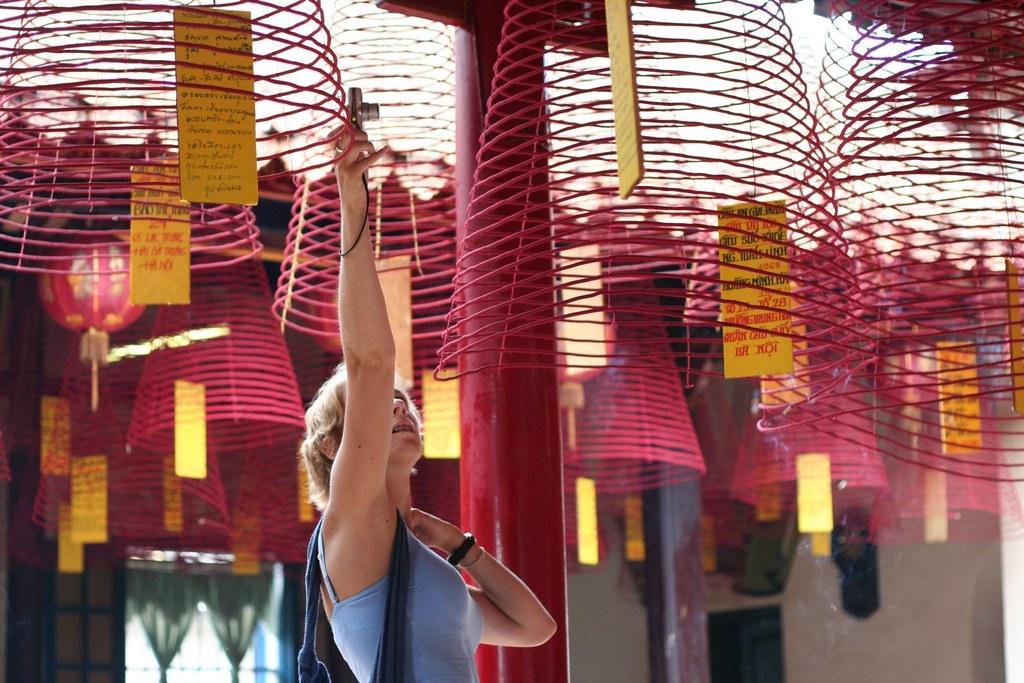Could you give a brief overview of what you see in this image? In this image we can see a lady taking picture with camera, there are some decorative objects are hanging, there are some cards with some text on it, there is a pole, window, curtains, walls, also we can see the sky. 